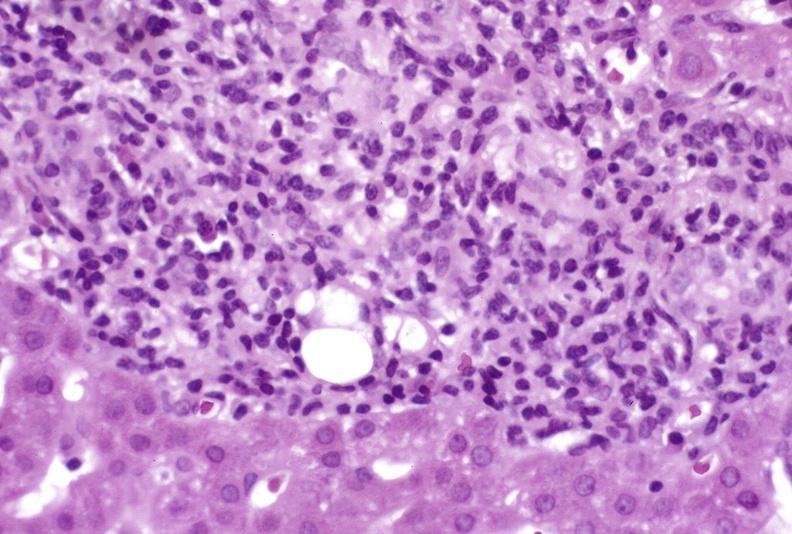s hepatobiliary present?
Answer the question using a single word or phrase. Yes 